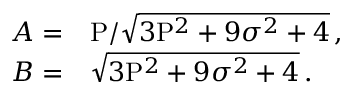Convert formula to latex. <formula><loc_0><loc_0><loc_500><loc_500>\begin{array} { r l } { A = } & P / \sqrt { 3 P ^ { 2 } + 9 \sigma ^ { 2 } + 4 } \, , } \\ { B = } & \sqrt { 3 P ^ { 2 } + 9 \sigma ^ { 2 } + 4 } \, . } \end{array}</formula> 